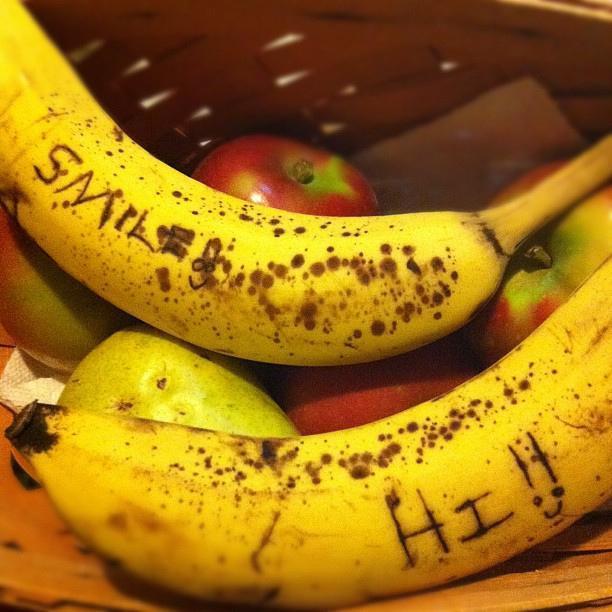How many apples can you see?
Give a very brief answer. 4. 